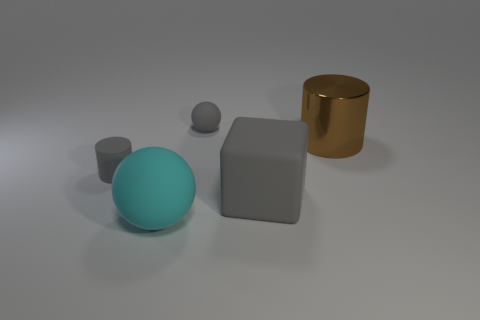Add 1 big gray matte blocks. How many objects exist? 6 Subtract all spheres. How many objects are left? 3 Subtract 0 yellow blocks. How many objects are left? 5 Subtract all big spheres. Subtract all tiny gray matte objects. How many objects are left? 2 Add 4 large brown objects. How many large brown objects are left? 5 Add 4 big gray cubes. How many big gray cubes exist? 5 